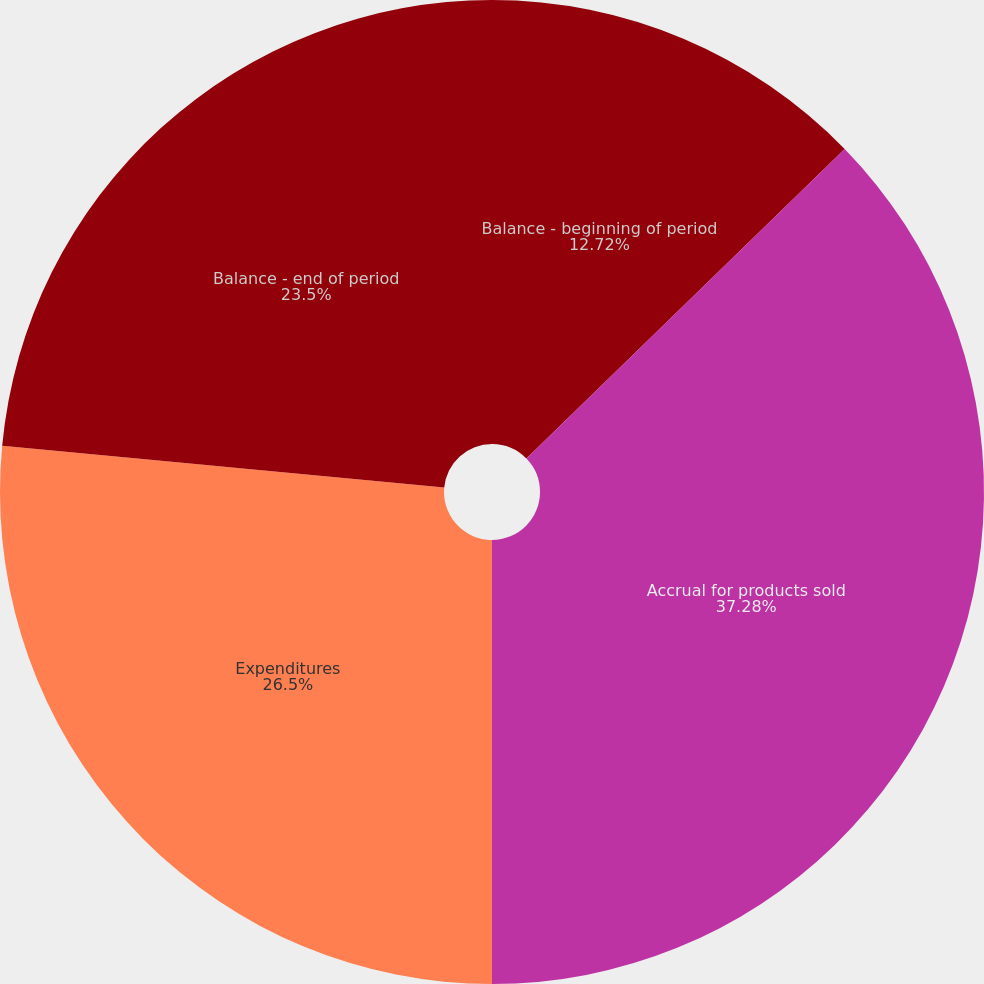Convert chart to OTSL. <chart><loc_0><loc_0><loc_500><loc_500><pie_chart><fcel>Balance - beginning of period<fcel>Accrual for products sold<fcel>Expenditures<fcel>Balance - end of period<nl><fcel>12.72%<fcel>37.28%<fcel>26.5%<fcel>23.5%<nl></chart> 